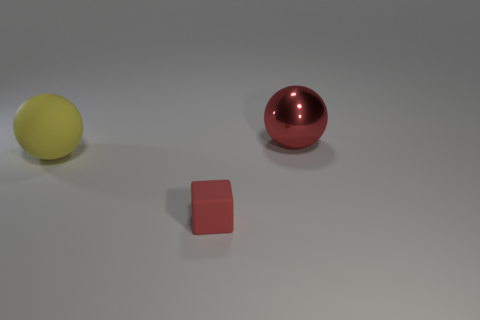What is the material of the thing that is the same color as the tiny rubber block?
Provide a short and direct response. Metal. How many matte cubes are behind the small red rubber cube that is in front of the large yellow object?
Keep it short and to the point. 0. Do the cube in front of the red metallic ball and the large sphere behind the large yellow matte sphere have the same color?
Your answer should be very brief. Yes. What is the material of the red sphere that is the same size as the yellow sphere?
Your answer should be compact. Metal. What shape is the large object that is to the right of the big ball that is in front of the large thing that is behind the big matte thing?
Ensure brevity in your answer.  Sphere. What number of things are on the right side of the rubber thing that is in front of the big ball on the left side of the big red metal thing?
Provide a succinct answer. 1. Is the number of big red balls that are behind the big rubber thing greater than the number of small red objects that are behind the tiny red matte block?
Provide a short and direct response. Yes. What number of other tiny red rubber things have the same shape as the tiny object?
Your answer should be very brief. 0. What number of objects are large objects that are left of the big red thing or objects that are right of the big yellow matte thing?
Provide a short and direct response. 3. There is a red object on the right side of the matte thing in front of the sphere left of the big metal sphere; what is it made of?
Make the answer very short. Metal. 